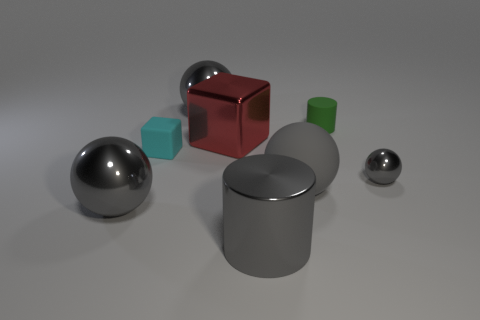Subtract all gray spheres. How many were subtracted if there are1gray spheres left? 3 Subtract all large gray spheres. How many spheres are left? 1 Subtract all cubes. How many objects are left? 6 Subtract all purple cylinders. Subtract all brown balls. How many cylinders are left? 2 Subtract all cyan cylinders. How many red cubes are left? 1 Subtract all tiny gray rubber things. Subtract all big red blocks. How many objects are left? 7 Add 6 big matte balls. How many big matte balls are left? 7 Add 2 large gray things. How many large gray things exist? 6 Add 2 large gray rubber spheres. How many objects exist? 10 Subtract 0 red spheres. How many objects are left? 8 